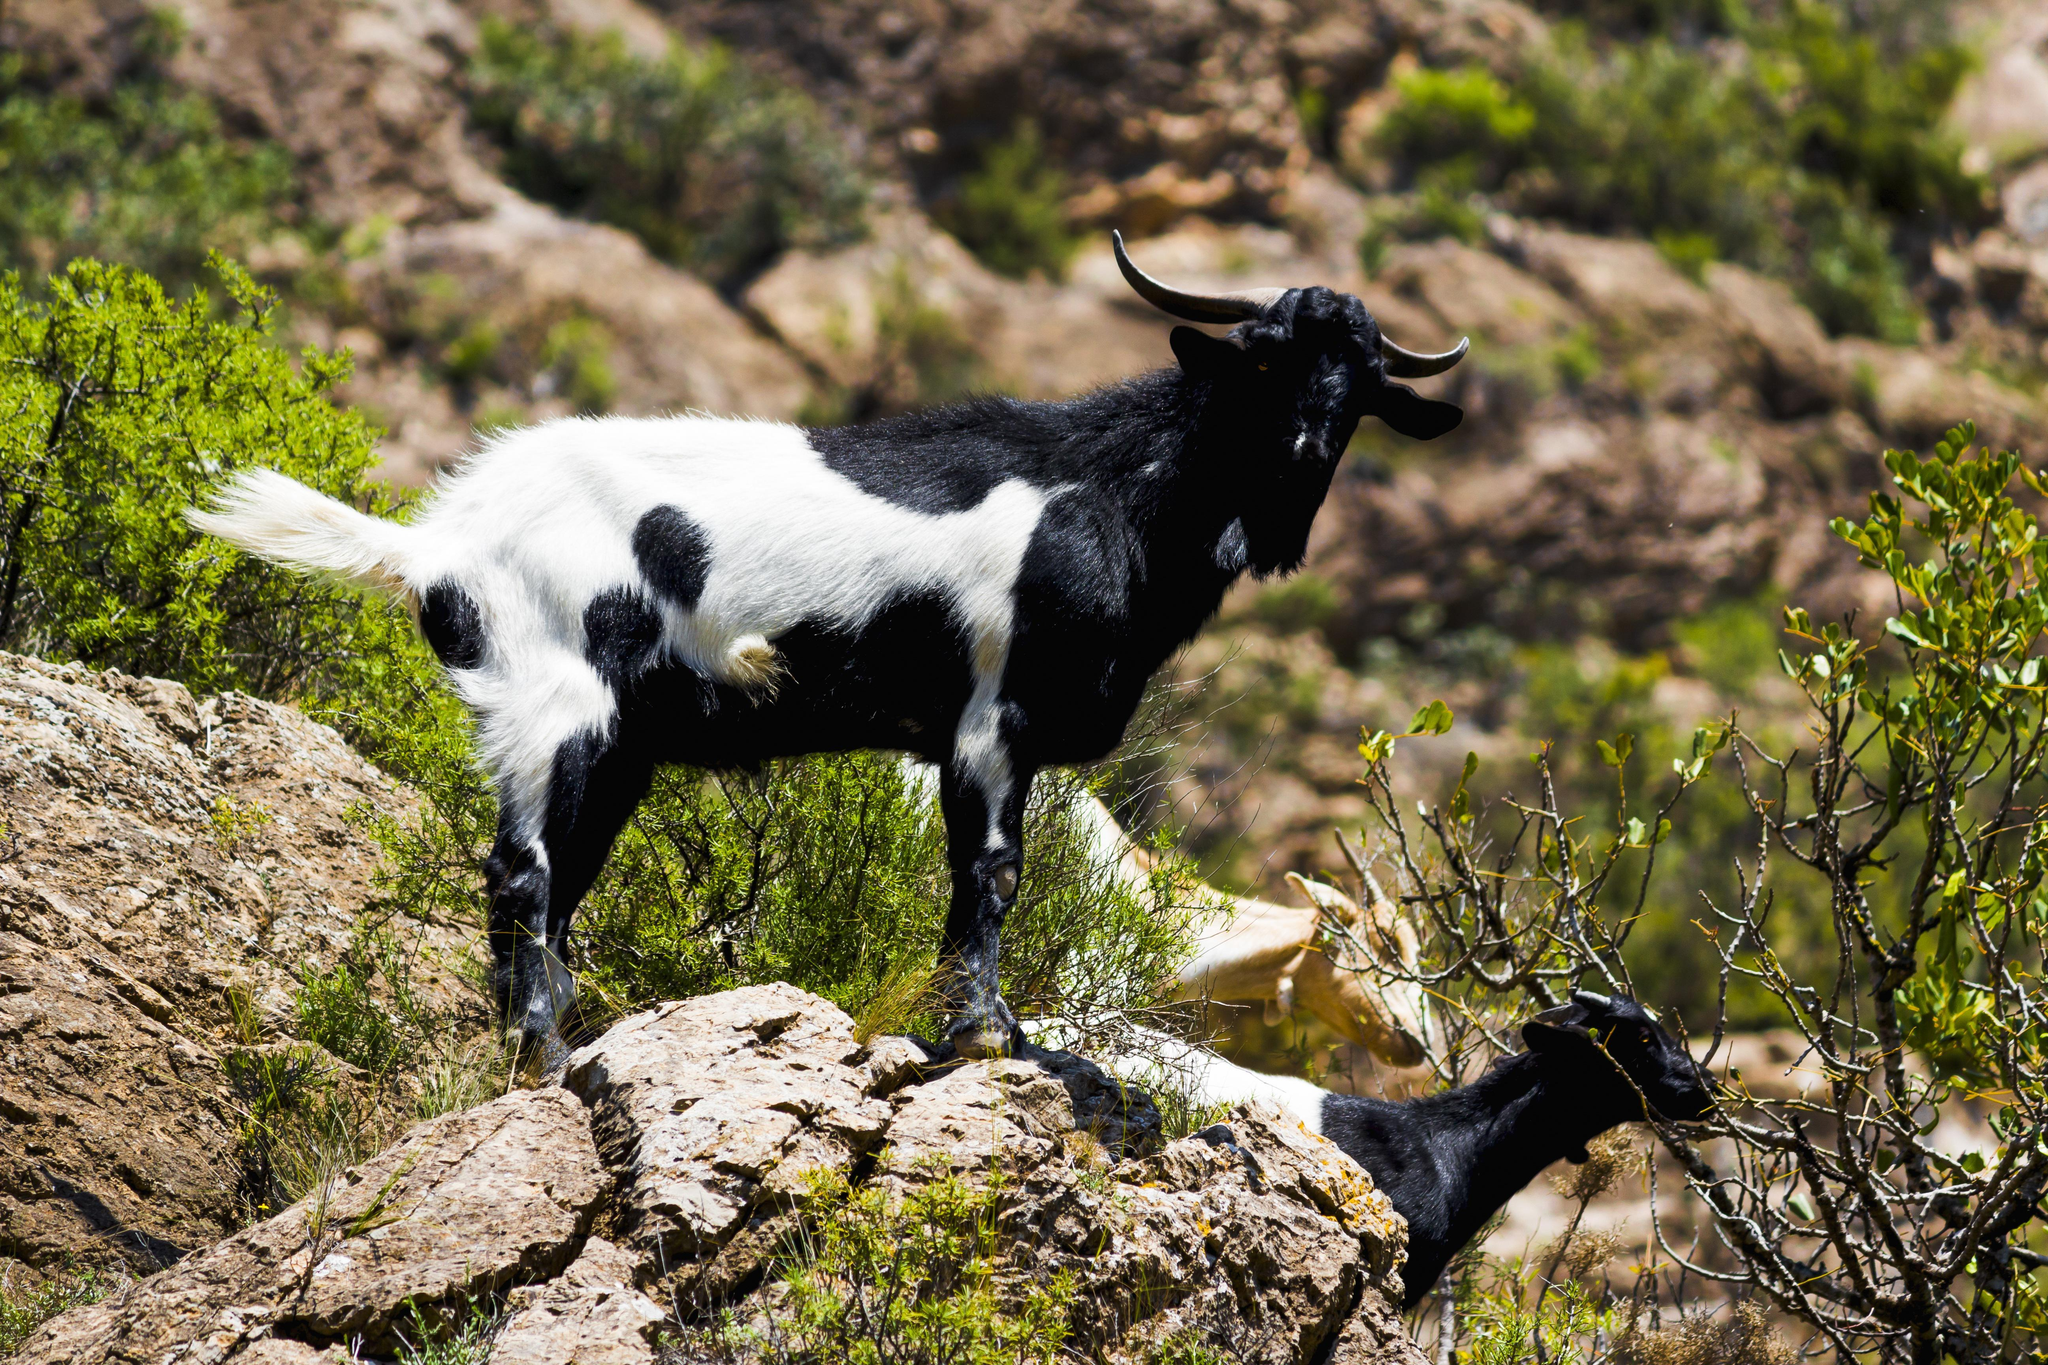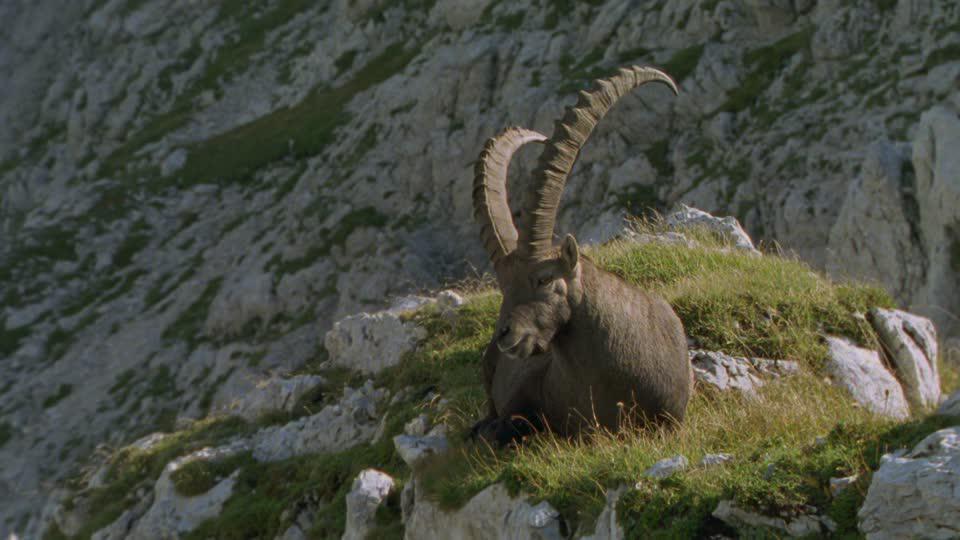The first image is the image on the left, the second image is the image on the right. Examine the images to the left and right. Is the description "An animal sits atop a rocky outcropping in the image on the right." accurate? Answer yes or no. Yes. 